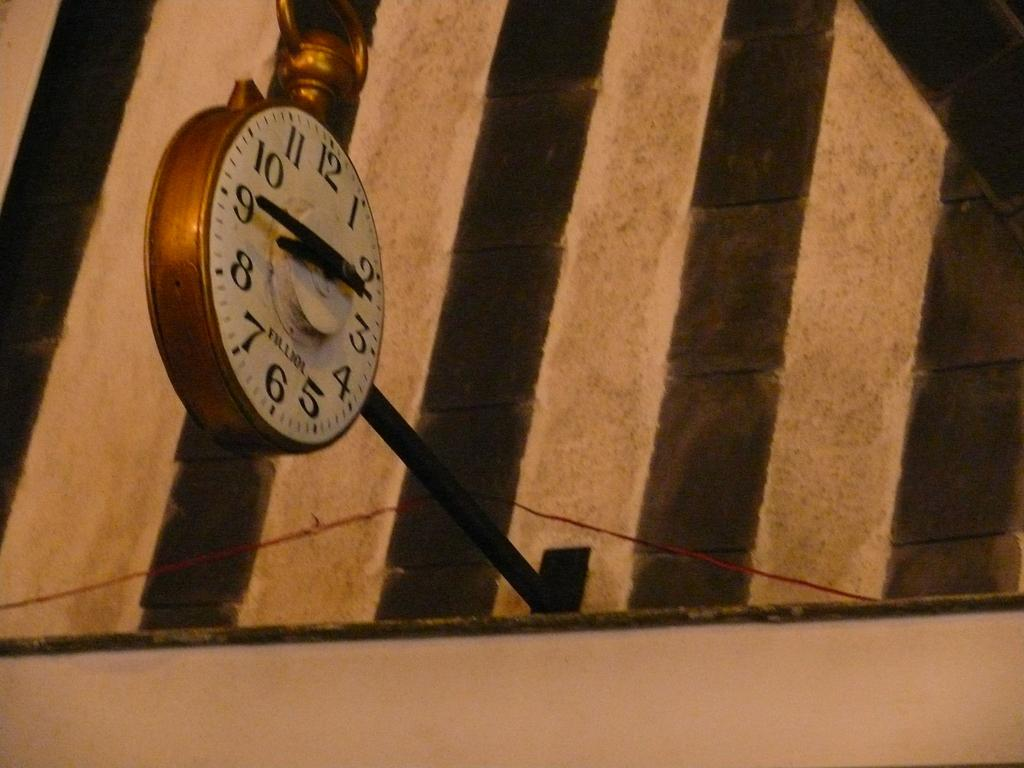<image>
Offer a succinct explanation of the picture presented. A clock hanging off a building, the time reads 8:45 